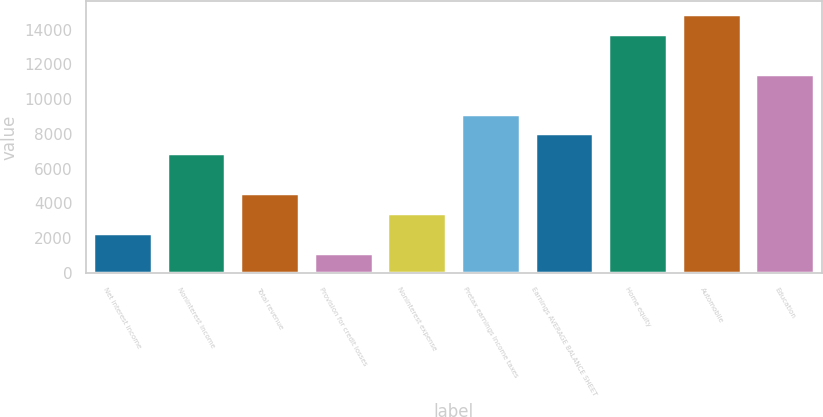Convert chart. <chart><loc_0><loc_0><loc_500><loc_500><bar_chart><fcel>Net interest income<fcel>Noninterest income<fcel>Total revenue<fcel>Provision for credit losses<fcel>Noninterest expense<fcel>Pretax earnings Income taxes<fcel>Earnings AVERAGE BALANCE SHEET<fcel>Home equity<fcel>Automobile<fcel>Education<nl><fcel>2305.2<fcel>6883.6<fcel>4594.4<fcel>1160.6<fcel>3449.8<fcel>9172.8<fcel>8028.2<fcel>13751.2<fcel>14895.8<fcel>11462<nl></chart> 